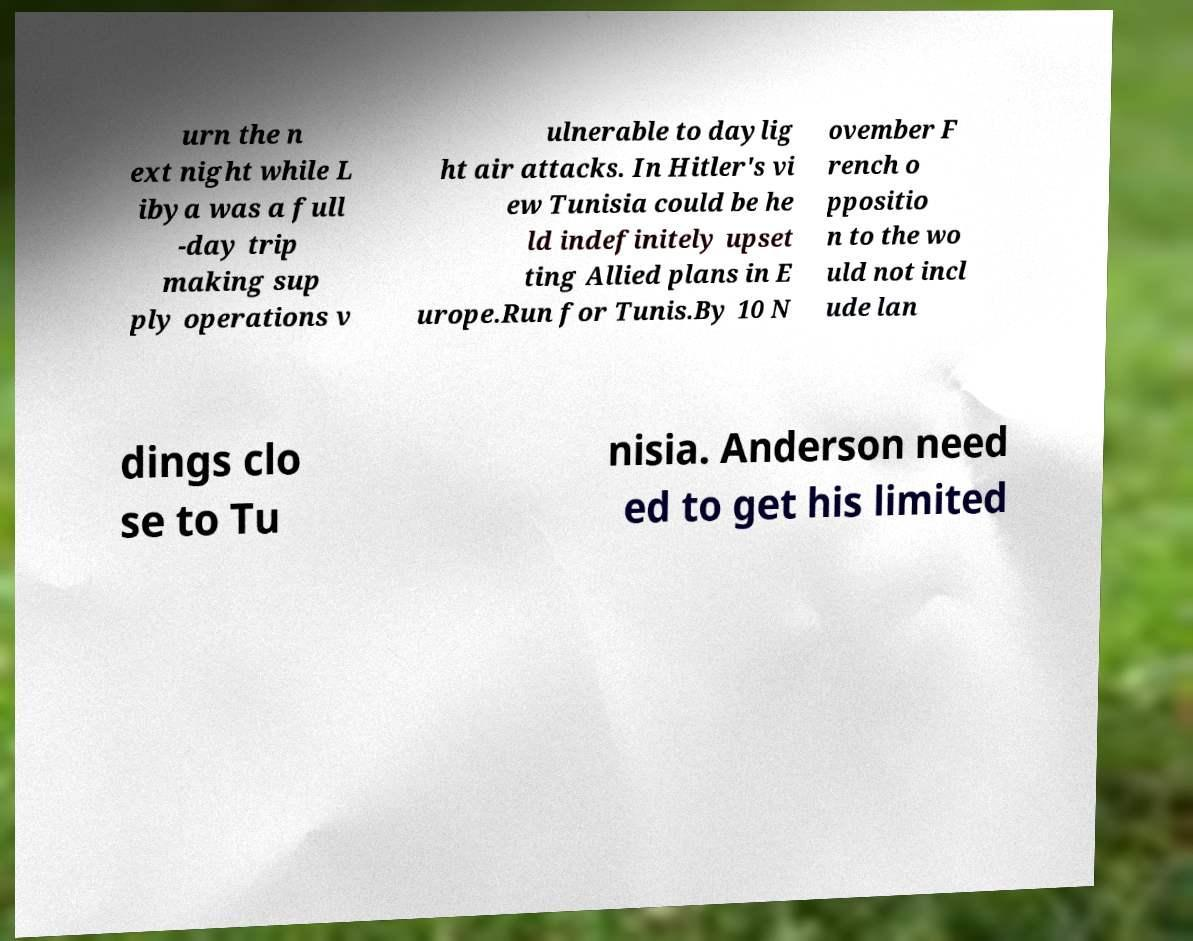What messages or text are displayed in this image? I need them in a readable, typed format. urn the n ext night while L ibya was a full -day trip making sup ply operations v ulnerable to daylig ht air attacks. In Hitler's vi ew Tunisia could be he ld indefinitely upset ting Allied plans in E urope.Run for Tunis.By 10 N ovember F rench o ppositio n to the wo uld not incl ude lan dings clo se to Tu nisia. Anderson need ed to get his limited 